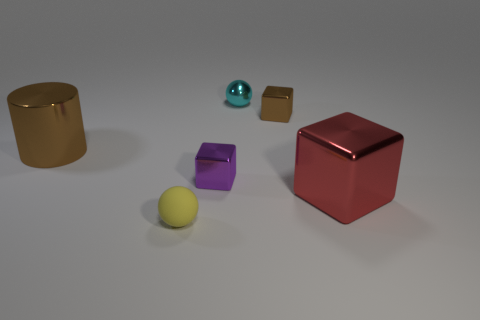Add 4 tiny green objects. How many objects exist? 10 Subtract all cylinders. How many objects are left? 5 Add 3 small purple metallic cubes. How many small purple metallic cubes are left? 4 Add 6 yellow rubber things. How many yellow rubber things exist? 7 Subtract 0 yellow cylinders. How many objects are left? 6 Subtract all small metallic blocks. Subtract all big brown matte cubes. How many objects are left? 4 